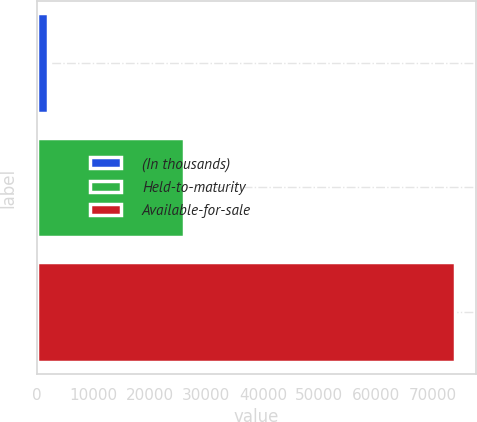<chart> <loc_0><loc_0><loc_500><loc_500><bar_chart><fcel>(In thousands)<fcel>Held-to-maturity<fcel>Available-for-sale<nl><fcel>2014<fcel>26034<fcel>73923<nl></chart> 